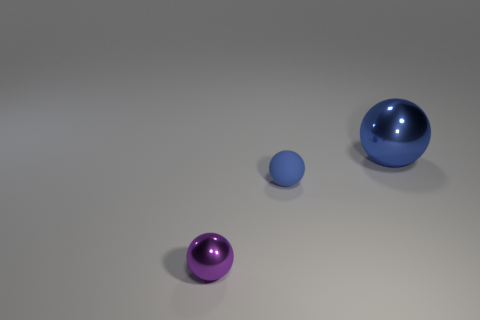Does the lighting in the scene give you any clues about the setting or time of day? The lighting in the image seems artificial with soft shadows, suggesting an indoor setting. It's not indicative of any particular time of day since the light source appears controlled. 